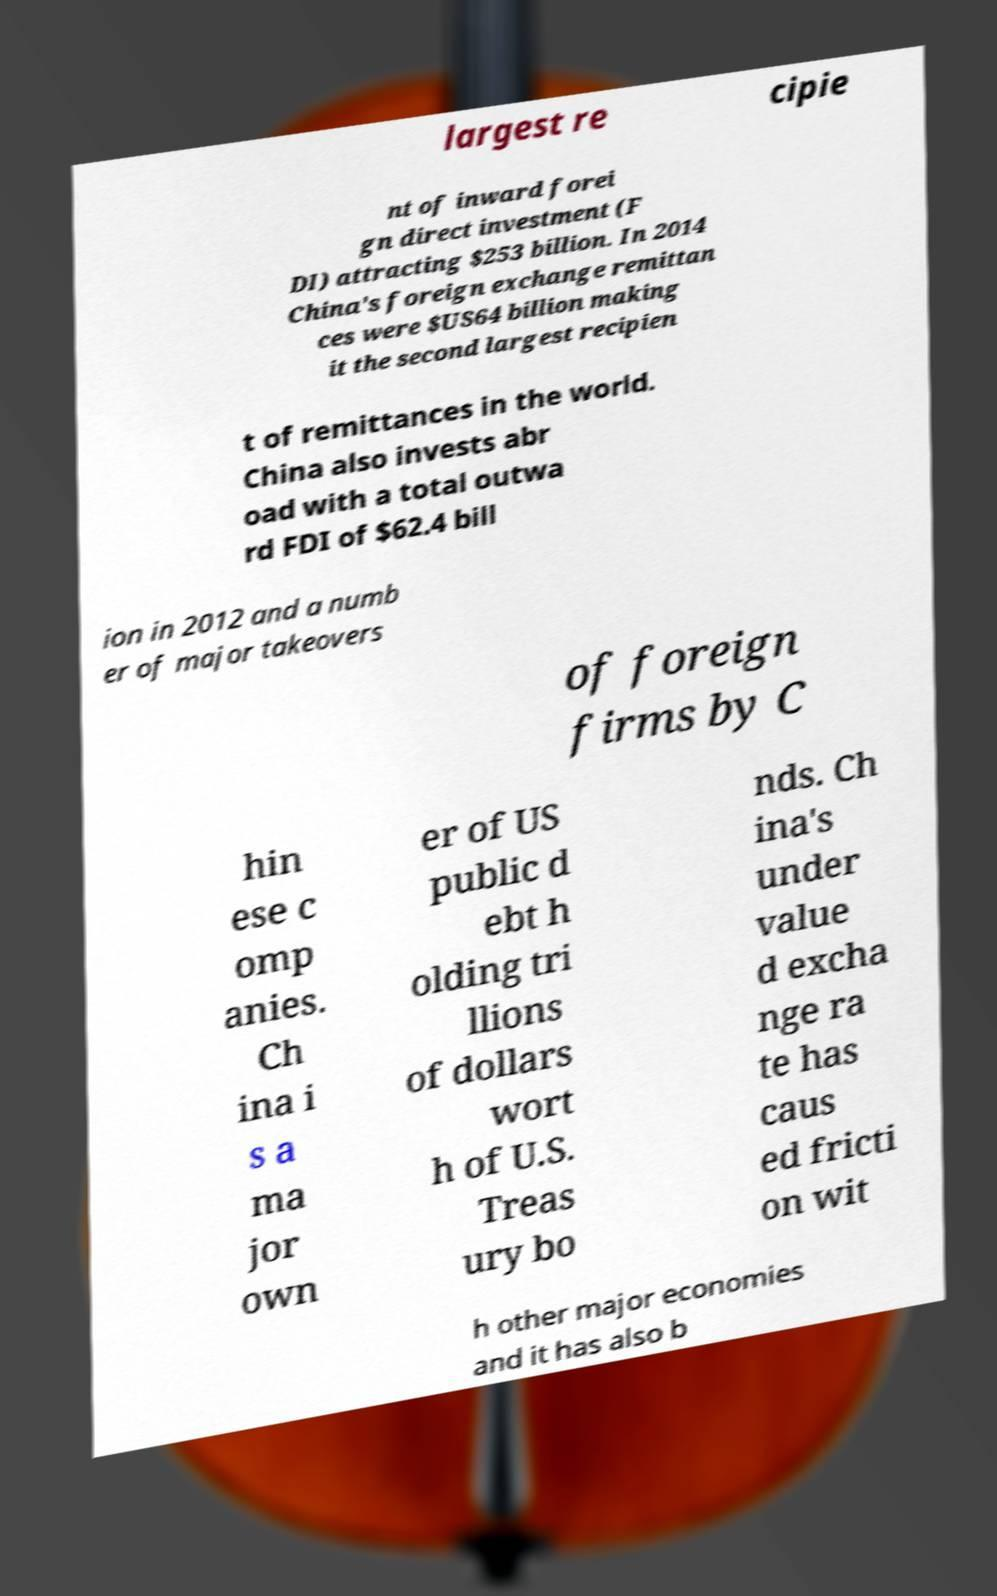Can you accurately transcribe the text from the provided image for me? largest re cipie nt of inward forei gn direct investment (F DI) attracting $253 billion. In 2014 China's foreign exchange remittan ces were $US64 billion making it the second largest recipien t of remittances in the world. China also invests abr oad with a total outwa rd FDI of $62.4 bill ion in 2012 and a numb er of major takeovers of foreign firms by C hin ese c omp anies. Ch ina i s a ma jor own er of US public d ebt h olding tri llions of dollars wort h of U.S. Treas ury bo nds. Ch ina's under value d excha nge ra te has caus ed fricti on wit h other major economies and it has also b 